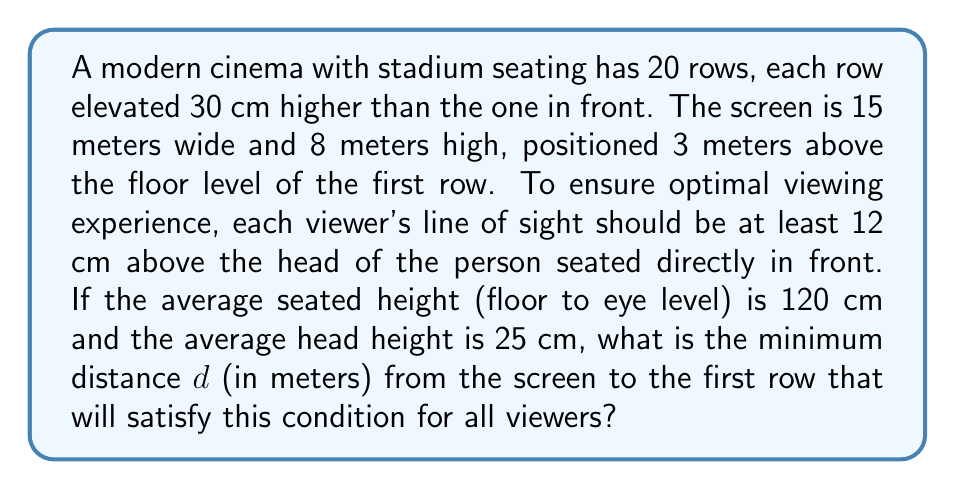Solve this math problem. Let's approach this step-by-step:

1) First, we need to calculate the angle $\theta$ from the top of the screen to the eyes of a viewer in the first row:

   $$\theta = \tan^{-1}\left(\frac{11 - 1.2}{d}\right)$$

   Where 11 m is the height of the top of the screen (3 m + 8 m) and 1.2 m is the eye level of a seated viewer.

2) Now, let's consider the worst-case scenario: a viewer in the last (20th) row trying to see over the head of someone in the 19th row.

3) The vertical distance between these two viewers' eyes is:

   $$0.3 \text{ m} \times 19 = 5.7 \text{ m}$$

4) The horizontal distance between these viewers is:

   $$19 \times \frac{d}{20}$$

5) For optimal viewing, we need:

   $$\tan(\theta) \geq \frac{5.7 - 0.12}{19 \times \frac{d}{20}}$$

   Where 0.12 m is the minimum clearance above the head.

6) Substituting the expression for $\tan(\theta)$:

   $$\frac{9.8}{d} \geq \frac{5.58}{19 \times \frac{d}{20}}$$

7) Simplifying:

   $$9.8 \times 19 \geq 5.58 \times 20$$
   $$186.2 \geq 111.6$$

8) This inequality is always true, so we need to find the minimum $d$ that satisfies the original condition:

   $$\frac{11 - 1.2}{d} \geq \frac{5.58}{19 \times \frac{d}{20}}$$

9) Solving for $d$:

   $$d^2 \geq \frac{5.58 \times 19 \times d}{9.8 \times 20}$$
   $$d \geq \frac{5.58 \times 19}{9.8 \times 20} \approx 5.37 \text{ m}$$

Therefore, the minimum distance from the screen to the first row should be at least 5.37 meters.
Answer: 5.37 m 